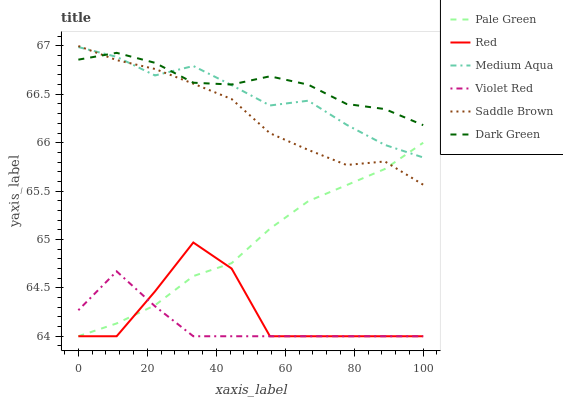Does Pale Green have the minimum area under the curve?
Answer yes or no. No. Does Pale Green have the maximum area under the curve?
Answer yes or no. No. Is Medium Aqua the smoothest?
Answer yes or no. No. Is Medium Aqua the roughest?
Answer yes or no. No. Does Medium Aqua have the lowest value?
Answer yes or no. No. Does Pale Green have the highest value?
Answer yes or no. No. Is Violet Red less than Dark Green?
Answer yes or no. Yes. Is Dark Green greater than Violet Red?
Answer yes or no. Yes. Does Violet Red intersect Dark Green?
Answer yes or no. No. 